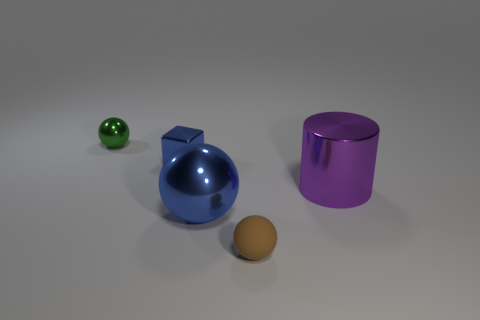There is a thing that is the same size as the purple cylinder; what shape is it?
Offer a terse response. Sphere. There is a metallic ball that is to the right of the green metal thing; does it have the same size as the big purple metallic cylinder?
Provide a short and direct response. Yes. What is the material of the brown thing that is the same size as the blue metallic block?
Offer a very short reply. Rubber. Are there any blue metallic blocks that are to the left of the large shiny object that is on the right side of the big metallic thing in front of the purple cylinder?
Give a very brief answer. Yes. Are there any other things that are the same shape as the large purple object?
Your answer should be compact. No. Does the metal cube behind the large blue metal thing have the same color as the shiny sphere on the right side of the tiny metal ball?
Keep it short and to the point. Yes. Is there a green metal thing?
Ensure brevity in your answer.  Yes. There is a small object that is the same color as the big metallic ball; what is it made of?
Make the answer very short. Metal. There is a cylinder that is in front of the blue metal object behind the large metal thing on the right side of the small matte sphere; how big is it?
Make the answer very short. Large. There is a brown rubber object; is it the same shape as the large metal thing that is in front of the big purple object?
Your answer should be compact. Yes. 